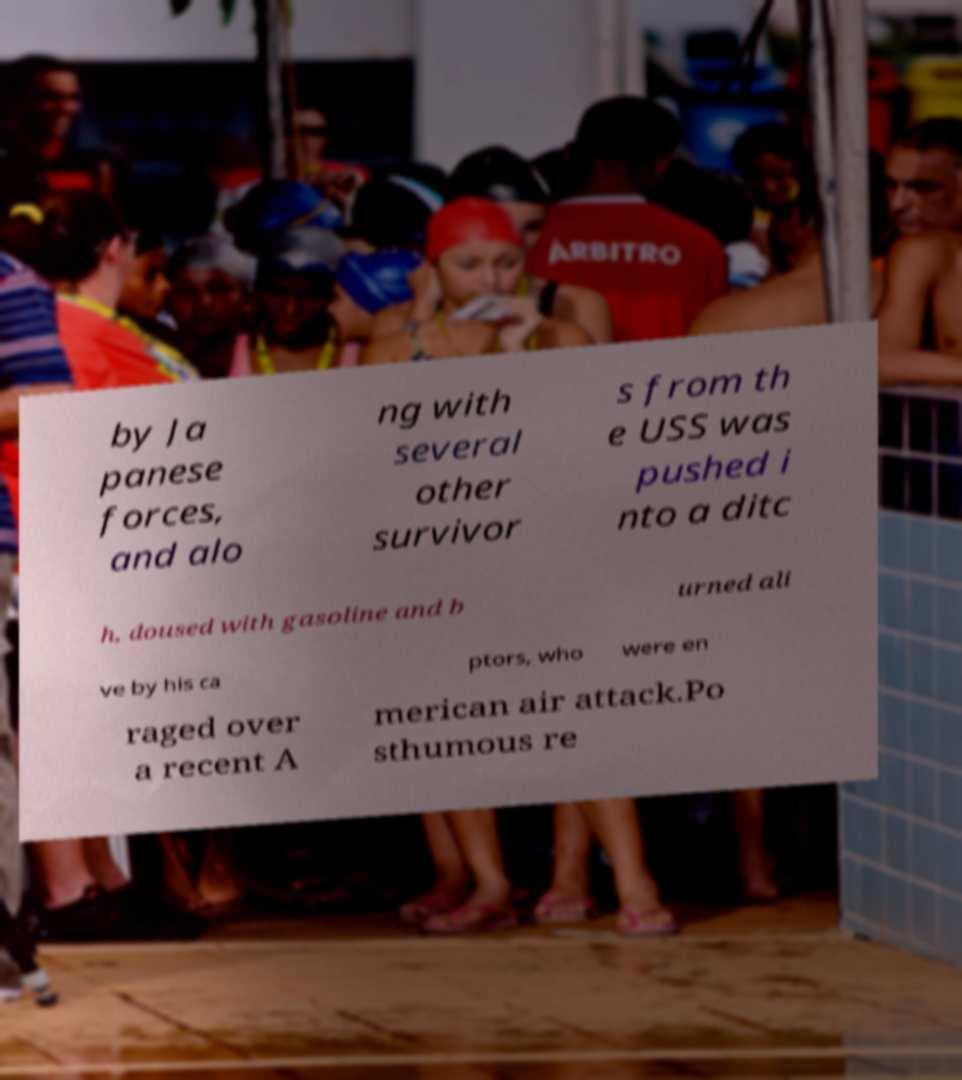Please identify and transcribe the text found in this image. by Ja panese forces, and alo ng with several other survivor s from th e USS was pushed i nto a ditc h, doused with gasoline and b urned ali ve by his ca ptors, who were en raged over a recent A merican air attack.Po sthumous re 